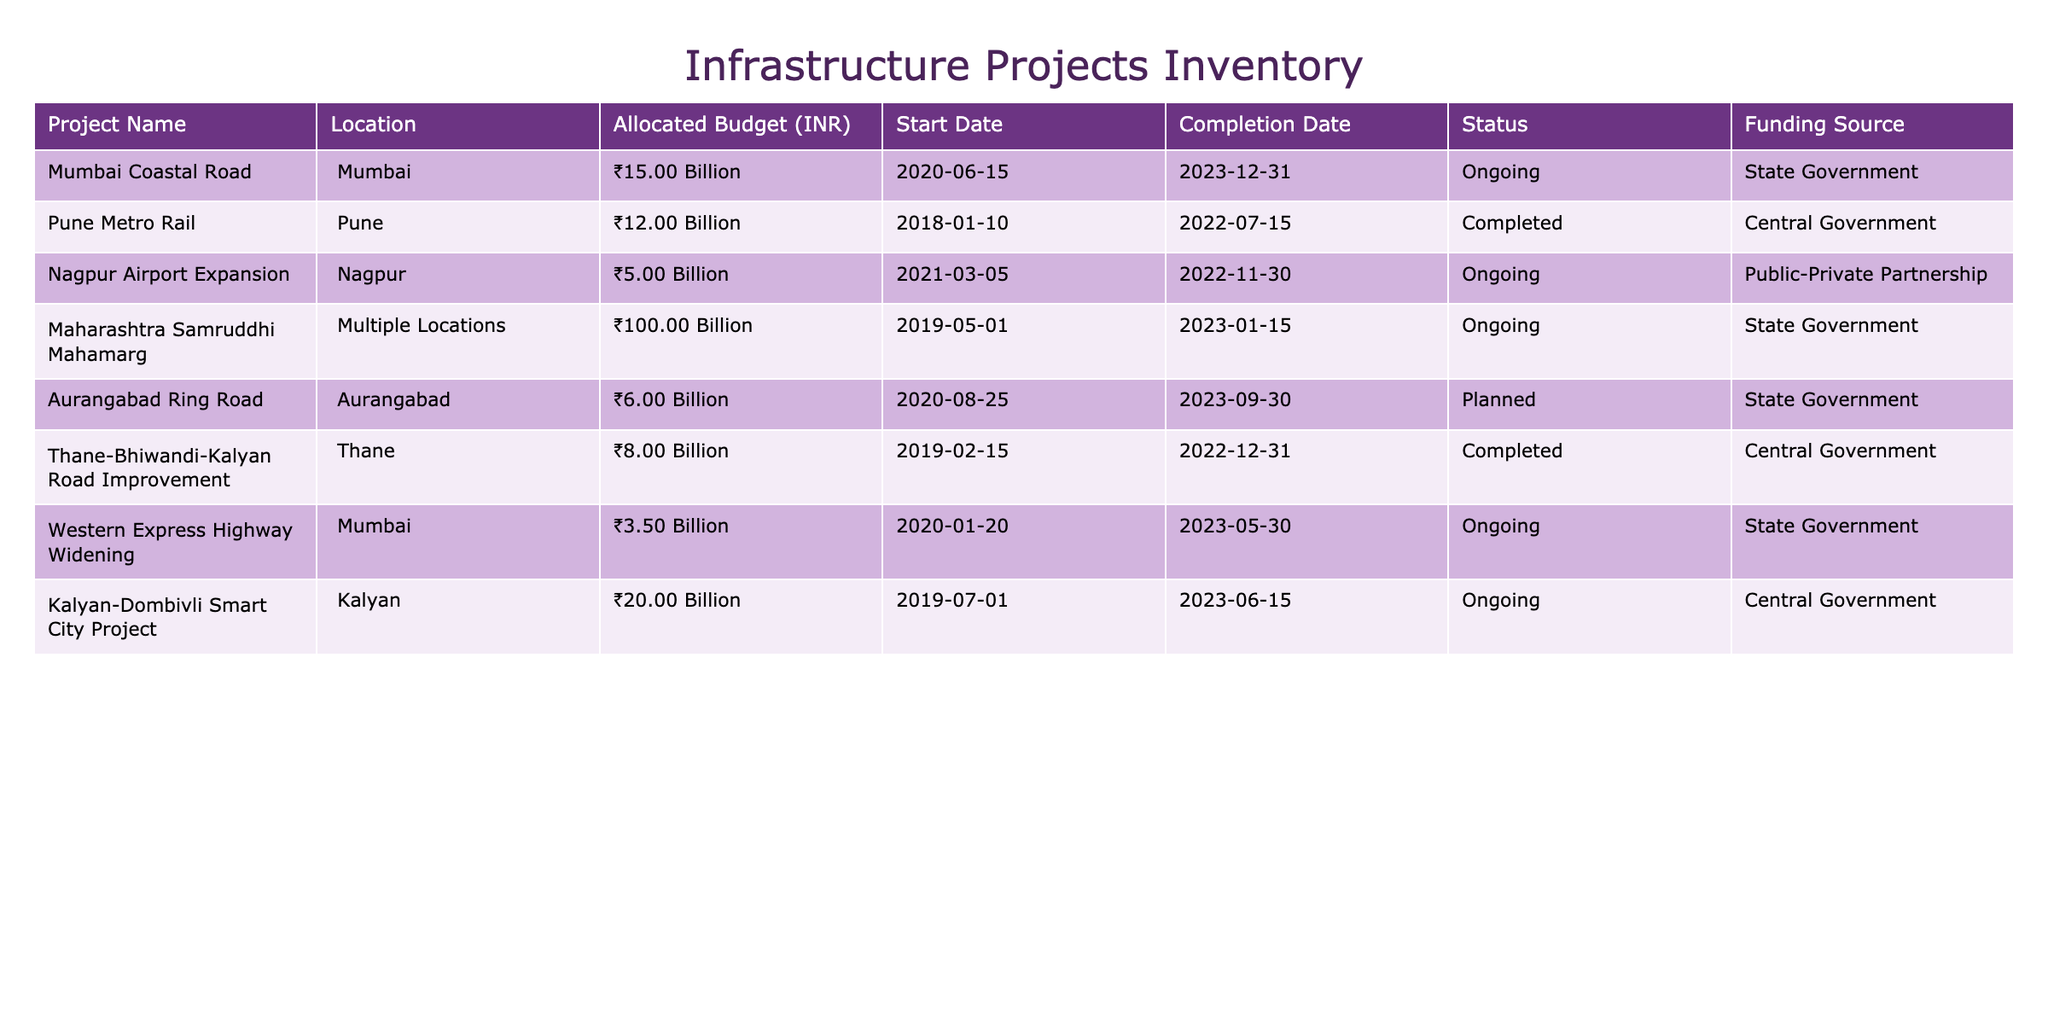What is the location of the Pune Metro Rail project? The table shows that the Pune Metro Rail project is located in Pune.
Answer: Pune Which project has the highest allocated budget? By examining the 'Allocated Budget' column, we see that the Maharashtra Samruddhi Mahamarg has the highest allocated budget of ₹100 Billion.
Answer: ₹100 Billion How many projects are currently ongoing? The table lists four projects with the status marked as 'Ongoing': Mumbai Coastal Road, Maharashtra Samruddhi Mahamarg, Western Express Highway Widening, and Kalyan-Dombivli Smart City Project. Therefore, there are four ongoing projects.
Answer: 4 What is the total allocated budget for projects funded by the State Government? The State Government funds three projects: Mumbai Coastal Road (₹15 Billion), Maharashtra Samruddhi Mahamarg (₹100 Billion), and Western Express Highway Widening (₹3.5 Billion). Adding these up gives ₹15 Billion + ₹100 Billion + ₹3.5 Billion = ₹118.5 Billion.
Answer: ₹118.5 Billion Is the Thane-Bhiwandi-Kalyan Road Improvement project completed? The status of the Thane-Bhiwandi-Kalyan Road Improvement project is marked as 'Completed' in the table, indicating that it has finished its work successfully.
Answer: Yes How many projects have been completed by the Central Government? The table shows two projects funded by the Central Government: the Pune Metro Rail (completed) and the Thane-Bhiwandi-Kalyan Road Improvement (completed). Therefore, there are two completed projects by the Central Government.
Answer: 2 What is the average budget allocation of completed projects? The completed projects are Pune Metro Rail (₹12 Billion) and Thane-Bhiwandi-Kalyan Road Improvement (₹8 Billion). Summing these gives ₹12 Billion + ₹8 Billion = ₹20 Billion. The average is then calculated as ₹20 Billion / 2 = ₹10 Billion.
Answer: ₹10 Billion Which project has the latest completion date? By examining the 'Completion Date' column, the Maharashtra Samruddhi Mahamarg project has the latest completion date of January 15, 2023.
Answer: Maharashtra Samruddhi Mahamarg Is there any project that has a planned status? The Aurangabad Ring Road project is marked as 'Planned' in the status column, indicating it has not yet started but is intended to be developed.
Answer: Yes 